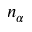<formula> <loc_0><loc_0><loc_500><loc_500>n _ { \alpha }</formula> 